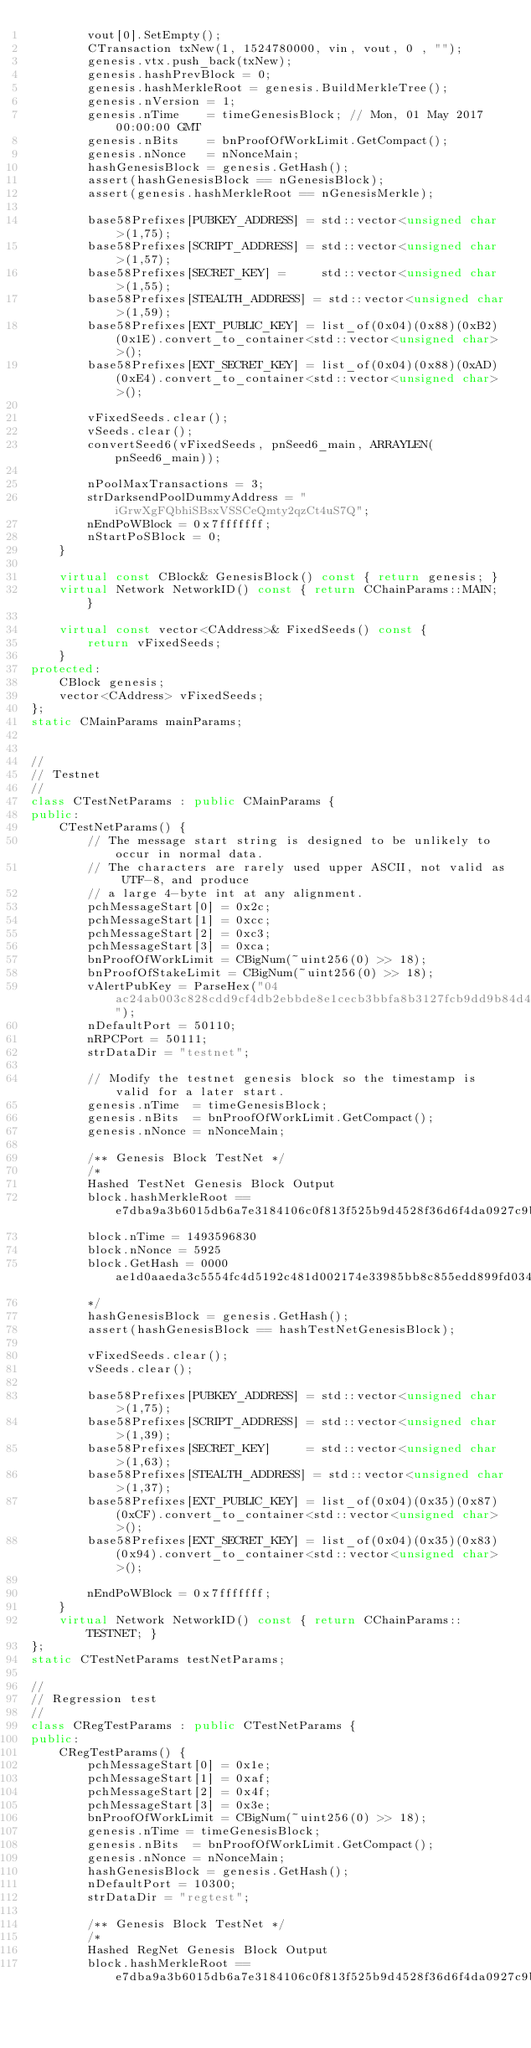<code> <loc_0><loc_0><loc_500><loc_500><_C++_>        vout[0].SetEmpty();
        CTransaction txNew(1, 1524780000, vin, vout, 0 , "");
        genesis.vtx.push_back(txNew);
        genesis.hashPrevBlock = 0;
        genesis.hashMerkleRoot = genesis.BuildMerkleTree();
        genesis.nVersion = 1;
        genesis.nTime    = timeGenesisBlock; // Mon, 01 May 2017 00:00:00 GMT
        genesis.nBits    = bnProofOfWorkLimit.GetCompact();
        genesis.nNonce   = nNonceMain;
        hashGenesisBlock = genesis.GetHash();
        assert(hashGenesisBlock == nGenesisBlock);
        assert(genesis.hashMerkleRoot == nGenesisMerkle);

        base58Prefixes[PUBKEY_ADDRESS] = std::vector<unsigned char>(1,75);
        base58Prefixes[SCRIPT_ADDRESS] = std::vector<unsigned char>(1,57);
        base58Prefixes[SECRET_KEY] =     std::vector<unsigned char>(1,55);
        base58Prefixes[STEALTH_ADDRESS] = std::vector<unsigned char>(1,59);
        base58Prefixes[EXT_PUBLIC_KEY] = list_of(0x04)(0x88)(0xB2)(0x1E).convert_to_container<std::vector<unsigned char> >();
        base58Prefixes[EXT_SECRET_KEY] = list_of(0x04)(0x88)(0xAD)(0xE4).convert_to_container<std::vector<unsigned char> >();

        vFixedSeeds.clear();
        vSeeds.clear();
        convertSeed6(vFixedSeeds, pnSeed6_main, ARRAYLEN(pnSeed6_main));

        nPoolMaxTransactions = 3;
        strDarksendPoolDummyAddress = "iGrwXgFQbhiSBsxVSSCeQmty2qzCt4uS7Q";
        nEndPoWBlock = 0x7fffffff;
        nStartPoSBlock = 0;
    }

    virtual const CBlock& GenesisBlock() const { return genesis; }
    virtual Network NetworkID() const { return CChainParams::MAIN; }

    virtual const vector<CAddress>& FixedSeeds() const {
        return vFixedSeeds;
    }
protected:
    CBlock genesis;
    vector<CAddress> vFixedSeeds;
};
static CMainParams mainParams;


//
// Testnet
//
class CTestNetParams : public CMainParams {
public:
    CTestNetParams() {
        // The message start string is designed to be unlikely to occur in normal data.
        // The characters are rarely used upper ASCII, not valid as UTF-8, and produce
        // a large 4-byte int at any alignment.
        pchMessageStart[0] = 0x2c;
        pchMessageStart[1] = 0xcc;
        pchMessageStart[2] = 0xc3;
        pchMessageStart[3] = 0xca;
        bnProofOfWorkLimit = CBigNum(~uint256(0) >> 18);
        bnProofOfStakeLimit = CBigNum(~uint256(0) >> 18);
        vAlertPubKey = ParseHex("04ac24ab003c828cdd9cf4db2ebbde8e1cecb3bbfa8b3127fcb9dd9b84d44112080827ed7c49a648af9fe788ff42e316aee665879c553f099e55299d6b54edd7e0");
        nDefaultPort = 50110;
        nRPCPort = 50111;
        strDataDir = "testnet";

        // Modify the testnet genesis block so the timestamp is valid for a later start.
        genesis.nTime  = timeGenesisBlock;
        genesis.nBits  = bnProofOfWorkLimit.GetCompact();
        genesis.nNonce = nNonceMain;

        /** Genesis Block TestNet */
        /*
        Hashed TestNet Genesis Block Output
        block.hashMerkleRoot == e7dba9a3b6015db6a7e3184106c0f813f525b9d4528f36d6f4da0927c9bf0a5f
        block.nTime = 1493596830
        block.nNonce = 5925
        block.GetHash = 0000ae1d0aaeda3c5554fc4d5192c481d002174e33985bb8c855edd899fd0346
        */
        hashGenesisBlock = genesis.GetHash();
        assert(hashGenesisBlock == hashTestNetGenesisBlock);

        vFixedSeeds.clear();
        vSeeds.clear();

        base58Prefixes[PUBKEY_ADDRESS] = std::vector<unsigned char>(1,75);
        base58Prefixes[SCRIPT_ADDRESS] = std::vector<unsigned char>(1,39);
        base58Prefixes[SECRET_KEY]     = std::vector<unsigned char>(1,63);
        base58Prefixes[STEALTH_ADDRESS] = std::vector<unsigned char>(1,37);
        base58Prefixes[EXT_PUBLIC_KEY] = list_of(0x04)(0x35)(0x87)(0xCF).convert_to_container<std::vector<unsigned char> >();
        base58Prefixes[EXT_SECRET_KEY] = list_of(0x04)(0x35)(0x83)(0x94).convert_to_container<std::vector<unsigned char> >();

        nEndPoWBlock = 0x7fffffff;
    }
    virtual Network NetworkID() const { return CChainParams::TESTNET; }
};
static CTestNetParams testNetParams;

//
// Regression test
//
class CRegTestParams : public CTestNetParams {
public:
    CRegTestParams() {
        pchMessageStart[0] = 0x1e;
        pchMessageStart[1] = 0xaf;
        pchMessageStart[2] = 0x4f;
        pchMessageStart[3] = 0x3e;
        bnProofOfWorkLimit = CBigNum(~uint256(0) >> 18);
        genesis.nTime = timeGenesisBlock;
        genesis.nBits  = bnProofOfWorkLimit.GetCompact();
        genesis.nNonce = nNonceMain;
        hashGenesisBlock = genesis.GetHash();
        nDefaultPort = 10300;
        strDataDir = "regtest";

        /** Genesis Block TestNet */
        /*
        Hashed RegNet Genesis Block Output
        block.hashMerkleRoot == e7dba9a3b6015db6a7e3184106c0f813f525b9d4528f36d6f4da0927c9bf0a5f</code> 